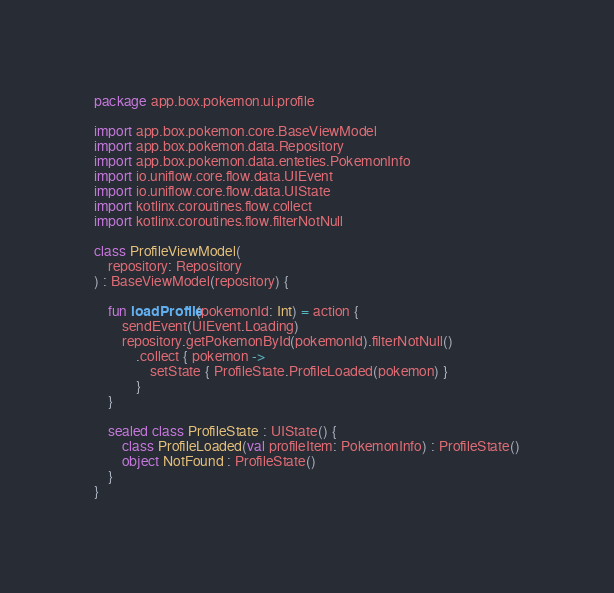<code> <loc_0><loc_0><loc_500><loc_500><_Kotlin_>package app.box.pokemon.ui.profile

import app.box.pokemon.core.BaseViewModel
import app.box.pokemon.data.Repository
import app.box.pokemon.data.enteties.PokemonInfo
import io.uniflow.core.flow.data.UIEvent
import io.uniflow.core.flow.data.UIState
import kotlinx.coroutines.flow.collect
import kotlinx.coroutines.flow.filterNotNull

class ProfileViewModel(
    repository: Repository
) : BaseViewModel(repository) {

    fun loadProfile(pokemonId: Int) = action {
        sendEvent(UIEvent.Loading)
        repository.getPokemonById(pokemonId).filterNotNull()
            .collect { pokemon ->
                setState { ProfileState.ProfileLoaded(pokemon) }
            }
    }

    sealed class ProfileState : UIState() {
        class ProfileLoaded(val profileItem: PokemonInfo) : ProfileState()
        object NotFound : ProfileState()
    }
}</code> 